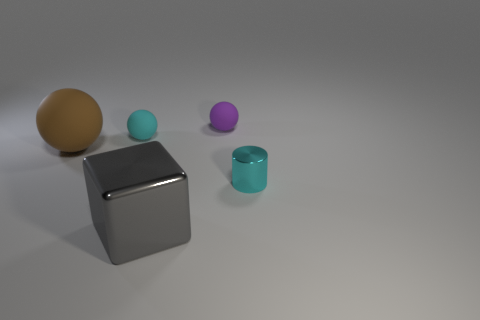Add 4 big metal objects. How many objects exist? 9 Subtract all green balls. Subtract all green cylinders. How many balls are left? 3 Subtract all balls. How many objects are left? 2 Add 5 gray objects. How many gray objects exist? 6 Subtract 0 blue cylinders. How many objects are left? 5 Subtract all green cubes. Subtract all cyan metallic cylinders. How many objects are left? 4 Add 1 purple objects. How many purple objects are left? 2 